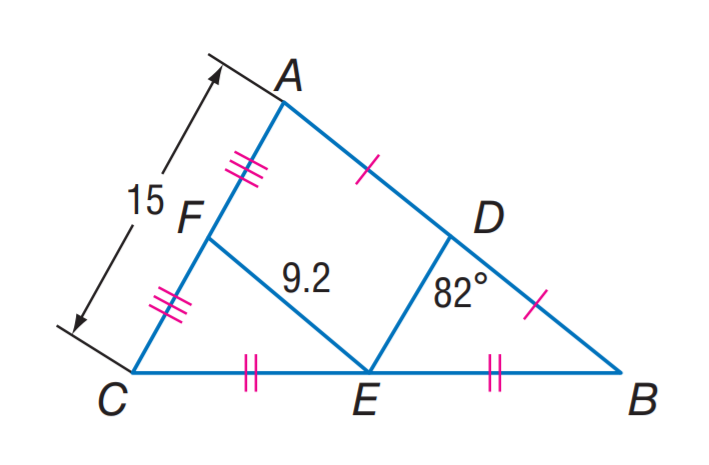Answer the mathemtical geometry problem and directly provide the correct option letter.
Question: Find D B.
Choices: A: 7.5 B: 9.2 C: 15 D: 18.4 B 